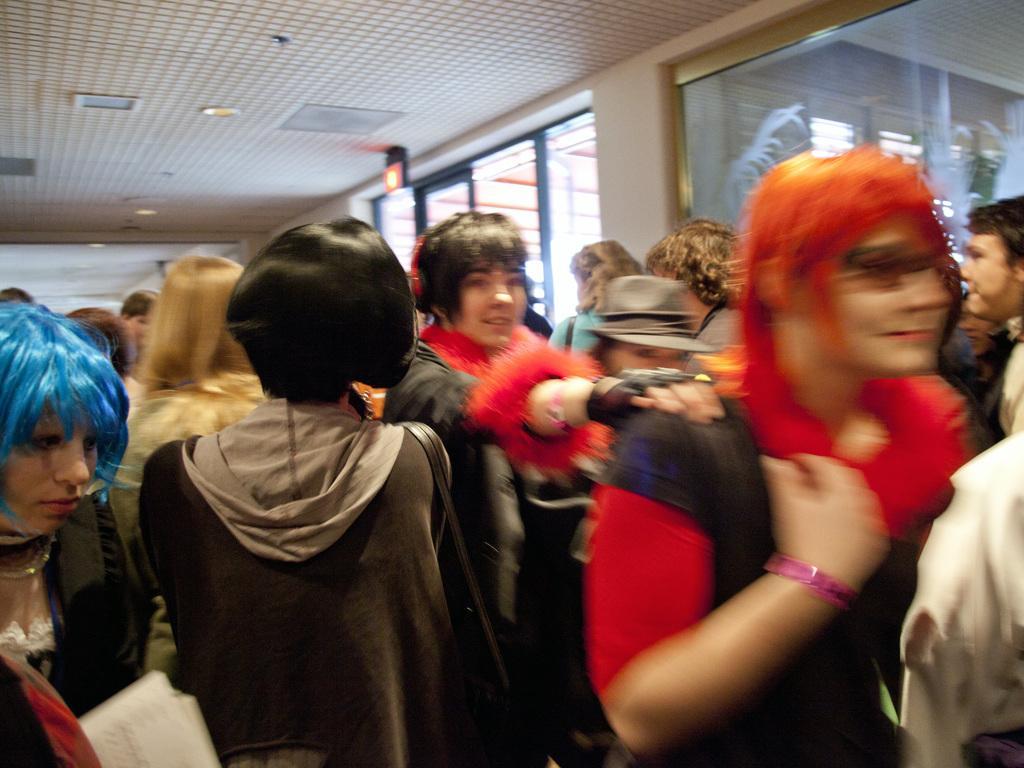Describe this image in one or two sentences. In this image we can see a few people standing, on the left side of the image we can see glass windows, at the top of the roof we can see some lights and other objects. 